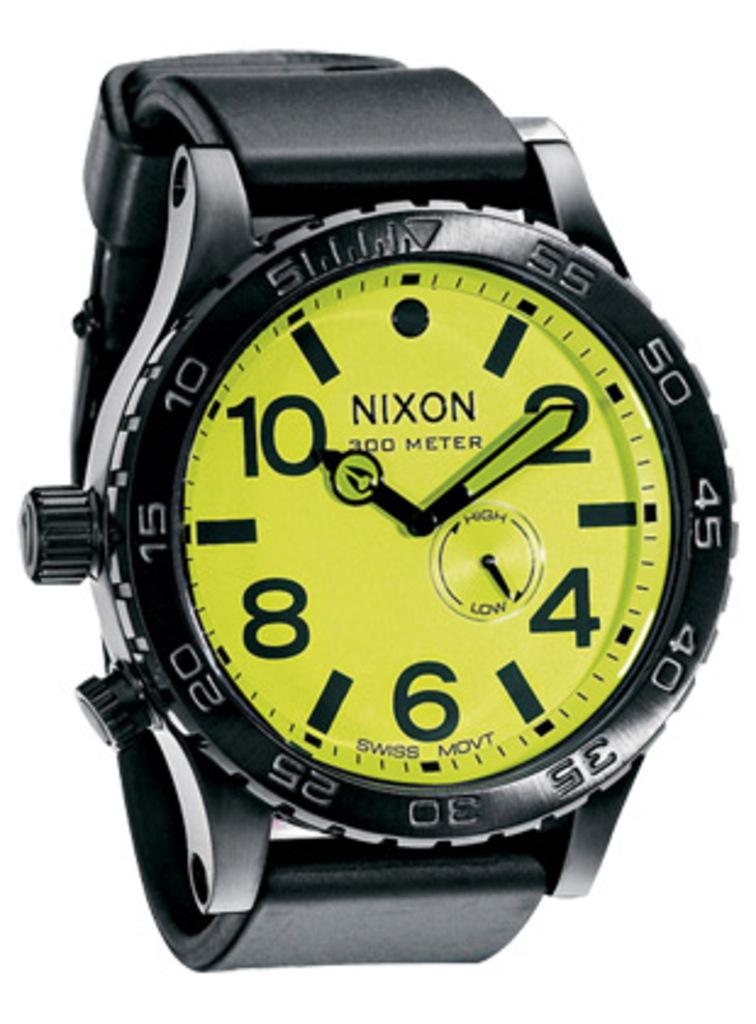<image>
Present a compact description of the photo's key features. Nixon is the brand of the hand watch. 